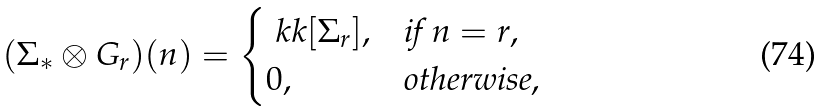<formula> <loc_0><loc_0><loc_500><loc_500>( \Sigma _ { * } \otimes G _ { r } ) ( n ) = \begin{cases} \ k k [ \Sigma _ { r } ] , & \text {if $n = r$} , \\ 0 , & \text {otherwise} , \end{cases}</formula> 